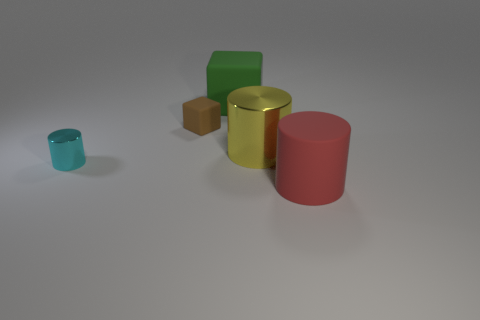Add 4 big red objects. How many objects exist? 9 Subtract 0 brown cylinders. How many objects are left? 5 Subtract all blocks. How many objects are left? 3 Subtract all blue shiny cylinders. Subtract all cyan shiny cylinders. How many objects are left? 4 Add 4 tiny brown things. How many tiny brown things are left? 5 Add 5 blue matte cylinders. How many blue matte cylinders exist? 5 